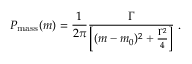<formula> <loc_0><loc_0><loc_500><loc_500>P _ { m a s s } ( m ) = \frac { 1 } { 2 \pi } \frac { \Gamma } { \left [ ( m - m _ { 0 } ) ^ { 2 } + \frac { \Gamma ^ { 2 } } { 4 } \right ] } \, .</formula> 